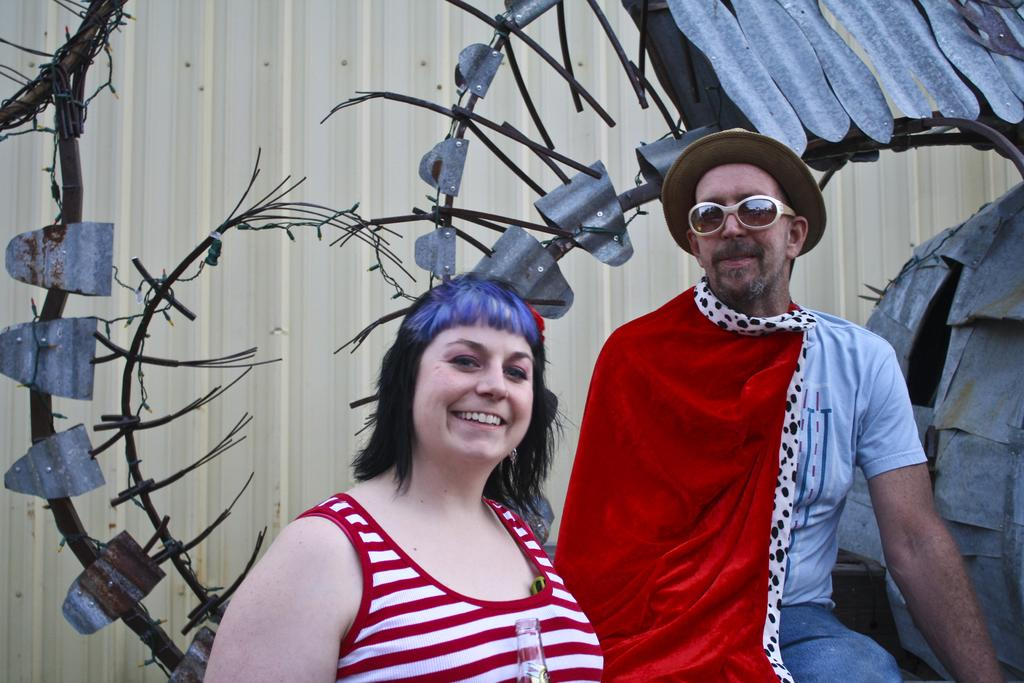How many people are in the image? There are two persons in the image. What expressions do the persons have? Both persons have smiling faces. What can be seen in the background of the image? There are metal objects visible in the background of the image. What is the size of the voice in the image? There is no voice present in the image, so it is not possible to determine its size. 